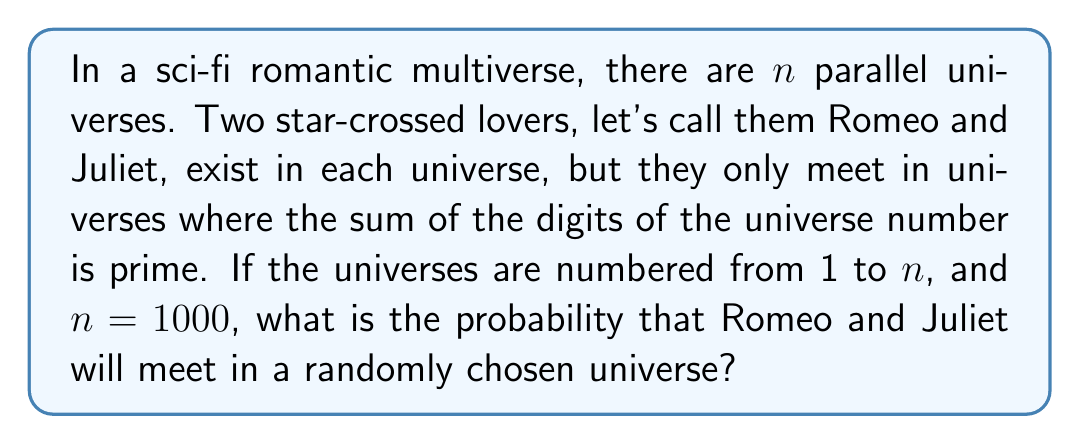Help me with this question. To solve this problem, we need to follow these steps:

1) First, we need to determine which universe numbers have a sum of digits that is prime.

2) The possible prime sums of digits are 2, 3, 5, 7, 11, 13, 17, 19, 23.

3) Let's count the universes for each sum:

   Sum 2: 2, 11, 20, 29, ..., 992 (100 universes)
   Sum 3: 3, 12, 21, 30, ..., 993 (100 universes)
   Sum 4: Not prime
   Sum 5: 5, 14, 23, 32, ..., 995 (100 universes)
   Sum 6: Not prime
   Sum 7: 7, 16, 25, 34, ..., 997 (100 universes)
   Sum 8: Not prime
   Sum 9: Not prime
   Sum 10: Not prime
   Sum 11: 29, 38, 47, 56, ..., 992 (90 universes)
   Sum 12: Not prime
   Sum 13: 49, 58, 67, 76, ..., 994 (90 universes)
   Sum 14: Not prime
   Sum 15: Not prime
   Sum 16: Not prime
   Sum 17: 89, 98, 179, 188, ..., 998 (36 universes)
   Sum 18: Not prime
   Sum 19: 199, 289, 298, 379, ..., 991 (28 universes)
   Sum 20: Not prime
   Sum 21: Not prime
   Sum 22: Not prime
   Sum 23: 599, 689, 698, 779, ..., 995 (10 universes)

4) Total number of universes where they meet: 
   $$100 + 100 + 100 + 100 + 90 + 90 + 36 + 28 + 10 = 654$$

5) The probability is the number of favorable outcomes divided by the total number of possible outcomes:

   $$P(\text{meeting}) = \frac{\text{Number of universes where they meet}}{\text{Total number of universes}} = \frac{654}{1000} = 0.654$$
Answer: The probability that Romeo and Juliet will meet in a randomly chosen universe is $\frac{654}{1000} = 0.654$ or $65.4\%$. 